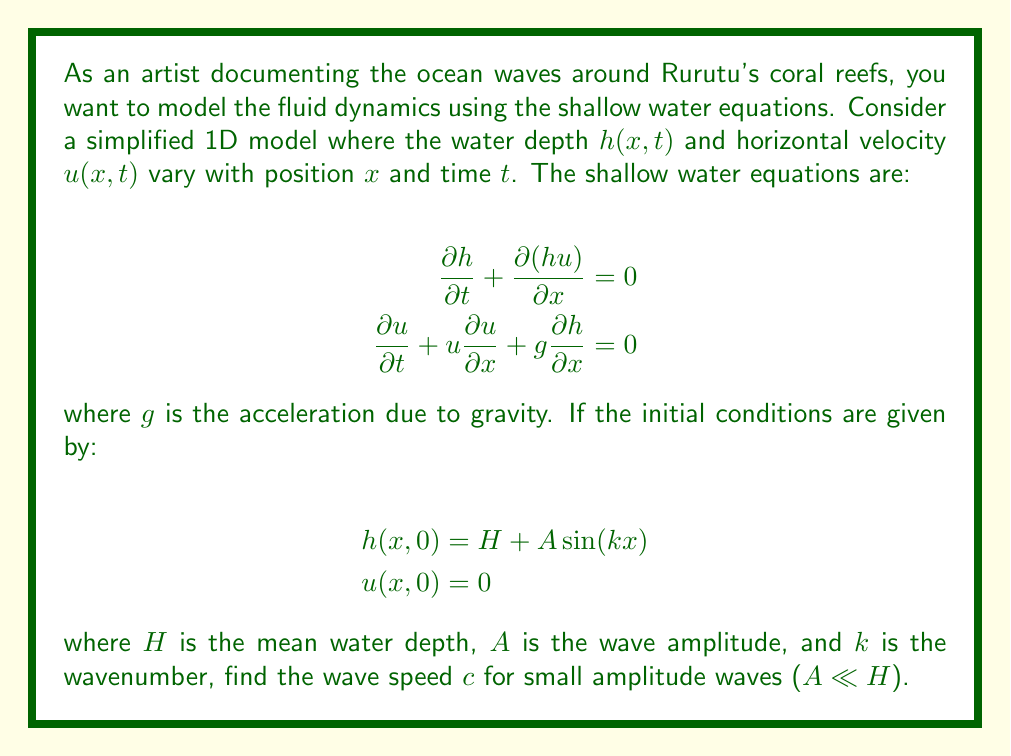Show me your answer to this math problem. To solve this problem, we'll use linearization of the shallow water equations for small amplitude waves:

1) First, assume small perturbations around the mean state:
   $$h(x,t) = H + \eta(x,t)$$
   $$u(x,t) = u'(x,t)$$
   where $\eta$ and $u'$ are small.

2) Substitute these into the shallow water equations and neglect products of small terms:

   $$\frac{\partial \eta}{\partial t} + H\frac{\partial u'}{\partial x} = 0$$
   $$\frac{\partial u'}{\partial t} + g\frac{\partial \eta}{\partial x} = 0$$

3) These linear equations admit wave solutions of the form:
   $$\eta(x,t) = A\cos(kx - \omega t)$$
   $$u'(x,t) = B\sin(kx - \omega t)$$

4) Substitute these into the linearized equations:
   $$-\omega A\sin(kx-\omega t) + HkB\cos(kx-\omega t) = 0$$
   $$-\omega B\cos(kx-\omega t) - gkA\sin(kx-\omega t) = 0$$

5) For these to be true for all $x$ and $t$, we must have:
   $$\omega A = HkB$$
   $$\omega B = gkA$$

6) Dividing these equations:
   $$\frac{\omega^2}{gk} = Hk$$

7) Solve for $\omega$:
   $$\omega = \sqrt{gHk^2}$$

8) The wave speed $c$ is given by:
   $$c = \frac{\omega}{k} = \sqrt{gH}$$

This is the wave speed for small amplitude waves in shallow water.
Answer: The wave speed for small amplitude waves is $c = \sqrt{gH}$, where $g$ is the acceleration due to gravity and $H$ is the mean water depth. 